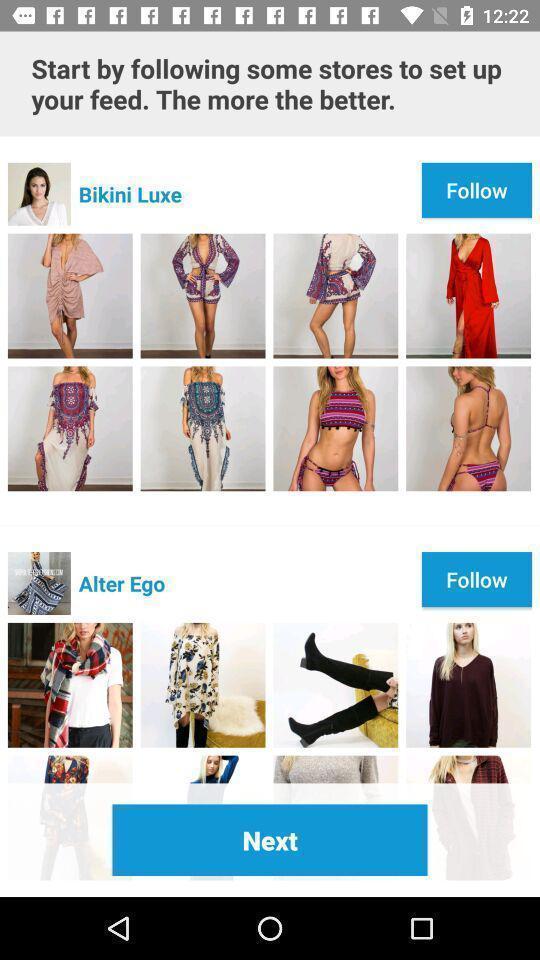What details can you identify in this image? Various clothing style feed displayed. 